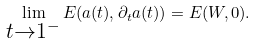Convert formula to latex. <formula><loc_0><loc_0><loc_500><loc_500>\lim _ { \substack { t \to 1 ^ { - } } } E ( a ( t ) , \partial _ { t } a ( t ) ) = E ( W , 0 ) .</formula> 